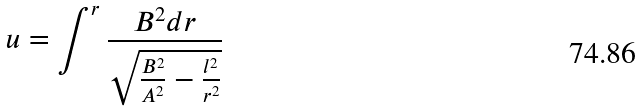<formula> <loc_0><loc_0><loc_500><loc_500>u = \int ^ { r } \frac { B ^ { 2 } d r } { \sqrt { \frac { B ^ { 2 } } { A ^ { 2 } } - \frac { l ^ { 2 } } { r ^ { 2 } } } }</formula> 